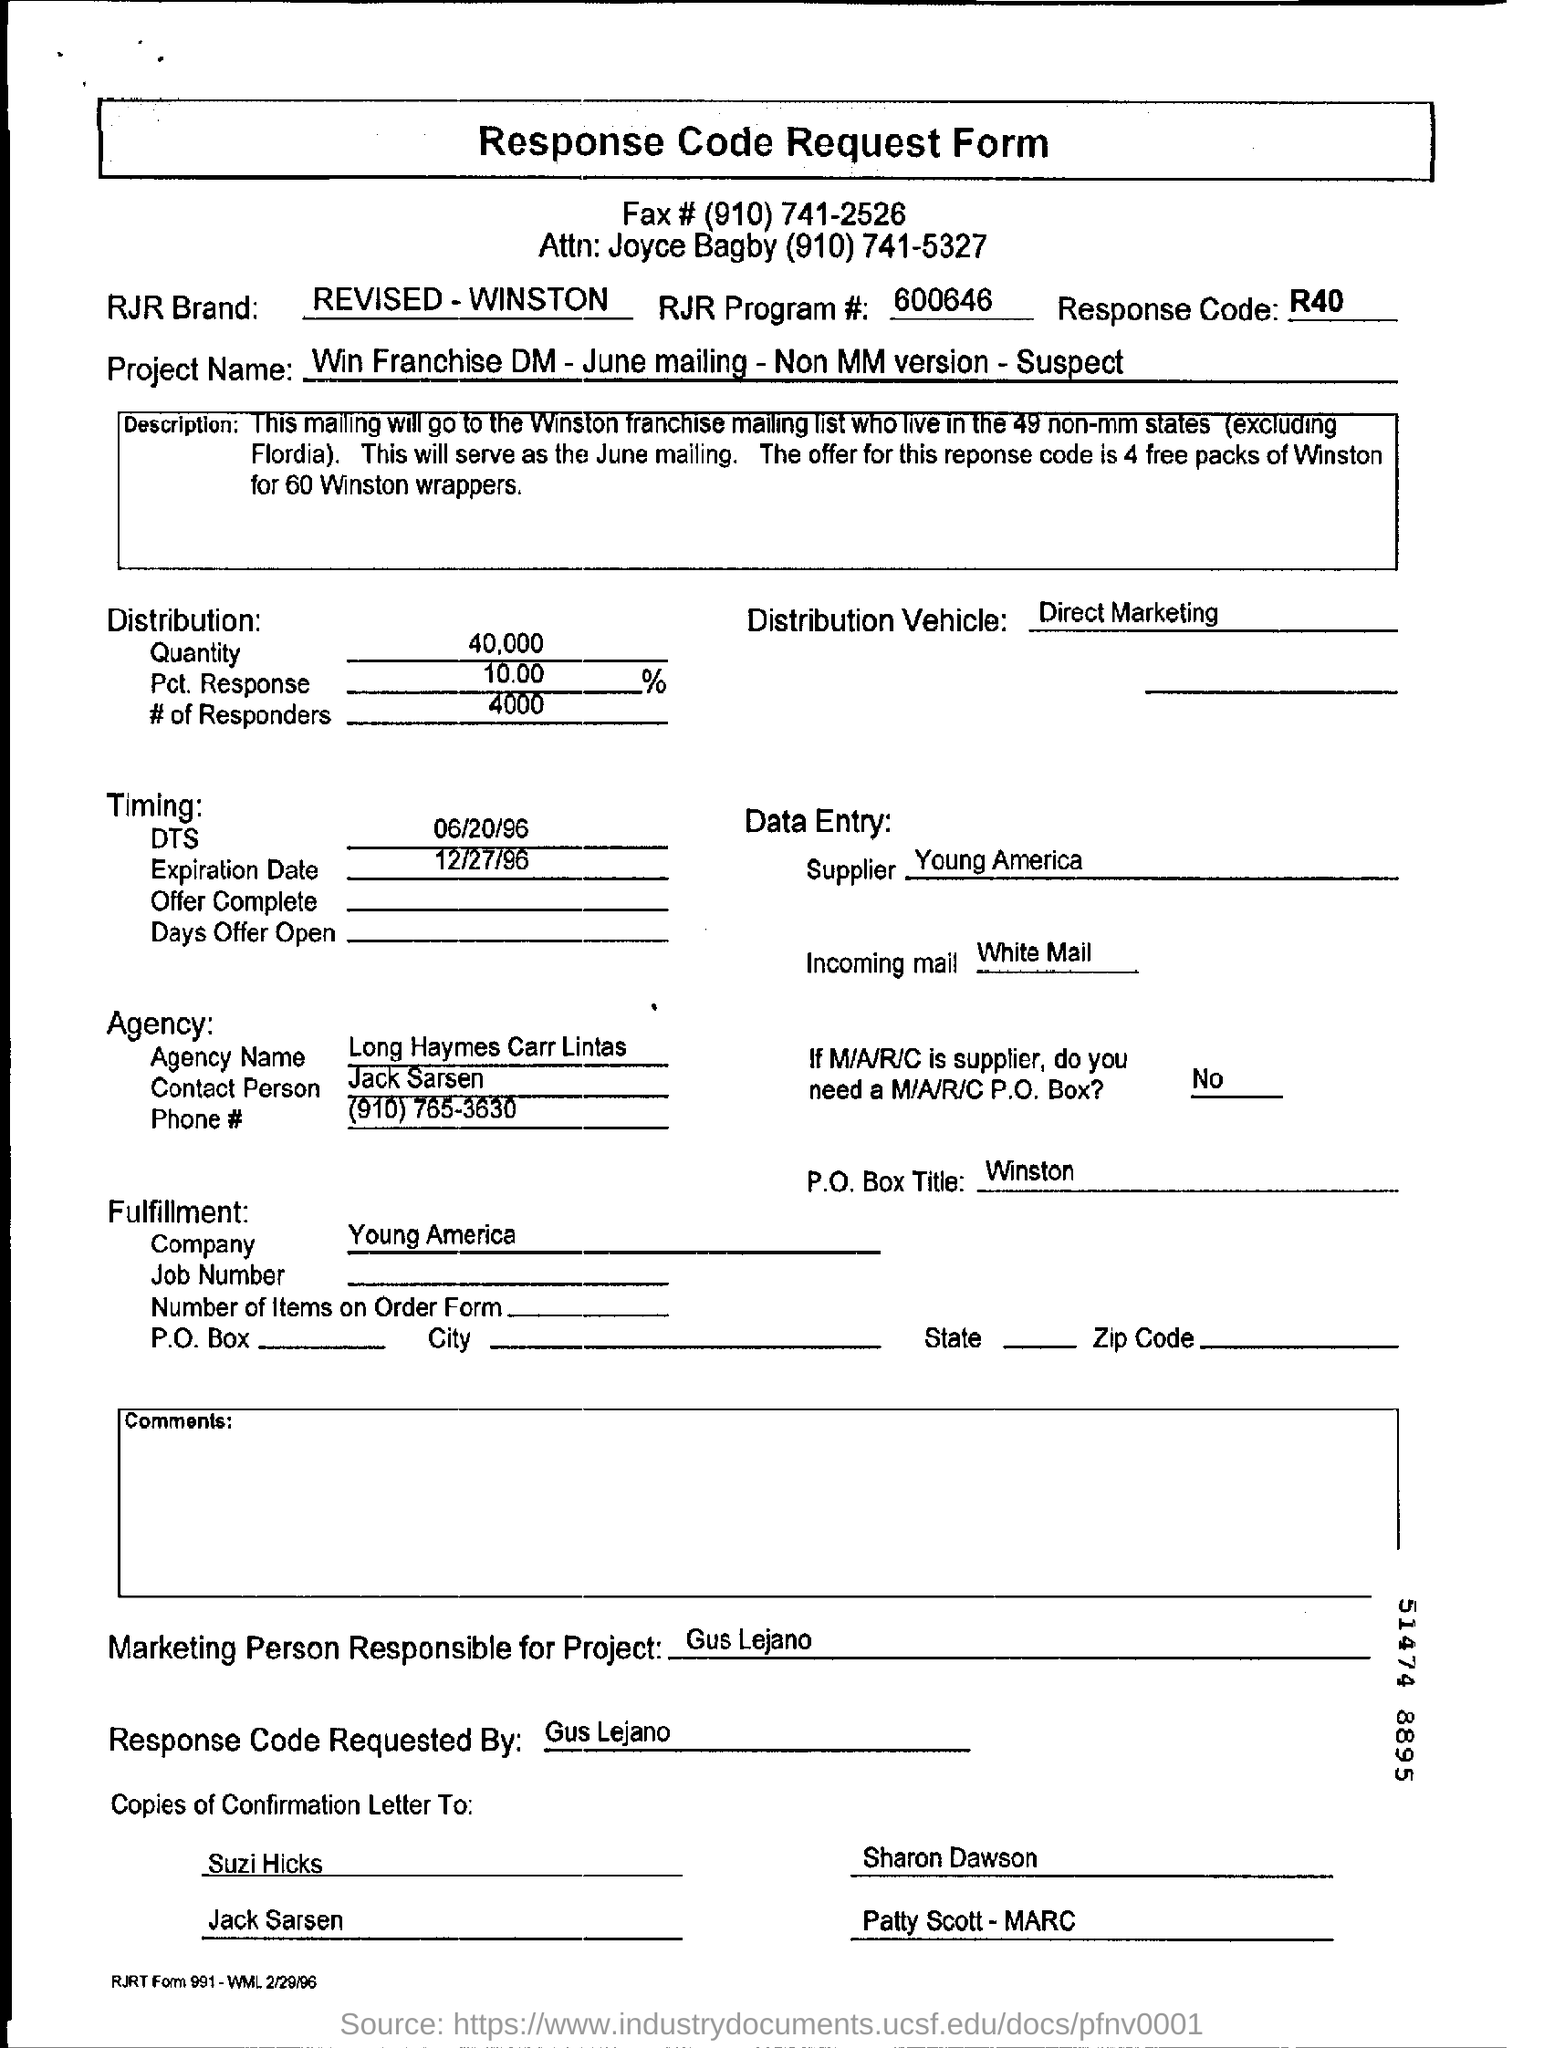List a handful of essential elements in this visual. It is Gus Lejano who is responsible for marketing in this matter. This project is named Win Franchise DM - June mailing - Non MM version - Suspect. The response code is R40. The response code was requested by ? gus Lejano. 